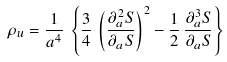Convert formula to latex. <formula><loc_0><loc_0><loc_500><loc_500>\rho _ { u } = \frac { 1 } { a ^ { 4 } } \, \left \{ \frac { 3 } { 4 } \, \left ( \frac { \partial _ { a } ^ { 2 } S } { \partial _ { a } S } \right ) ^ { 2 } - \frac { 1 } { 2 } \, \frac { \partial _ { a } ^ { 3 } S } { \partial _ { a } S } \right \}</formula> 